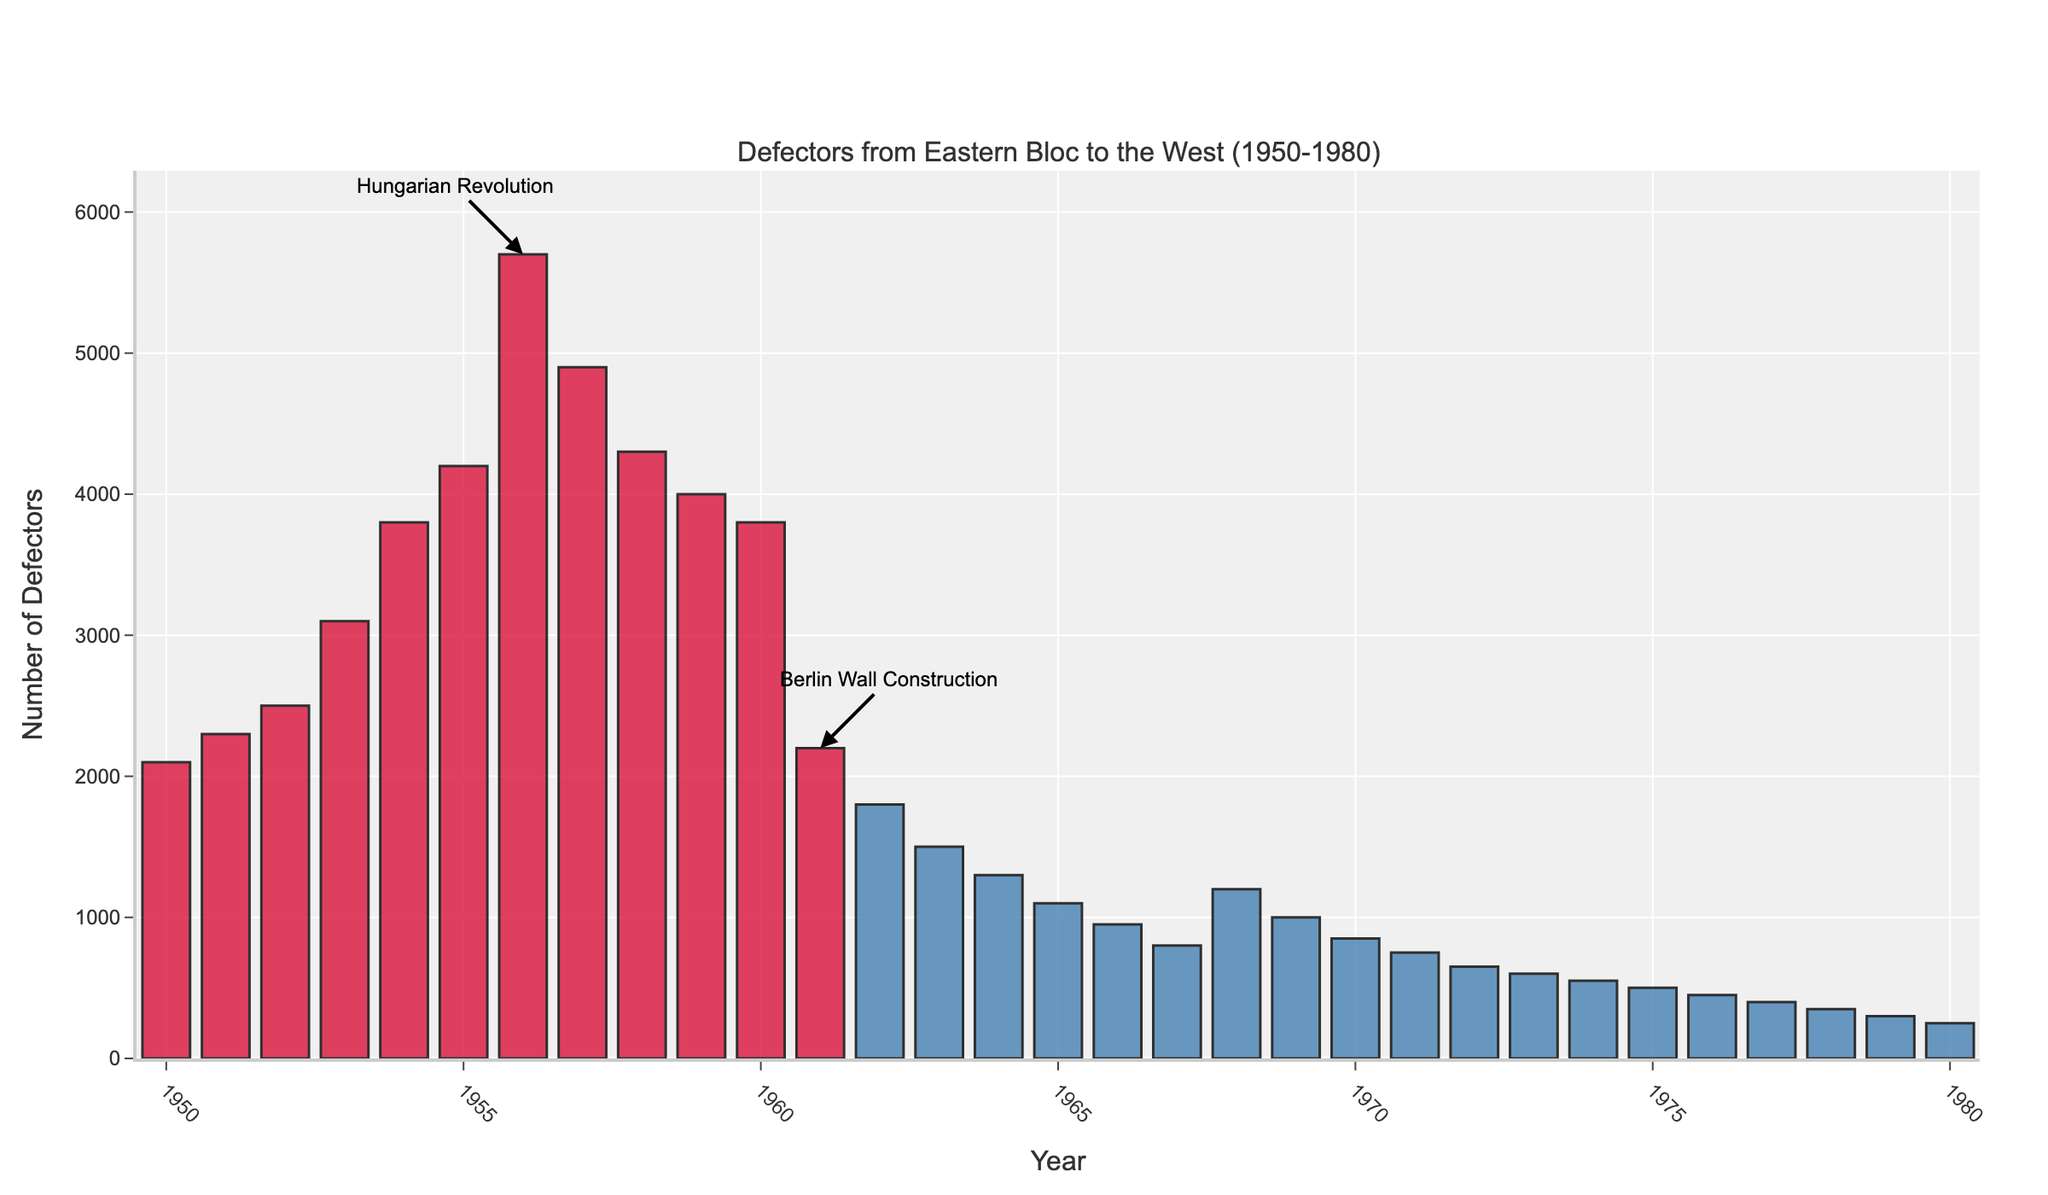Which year had the highest number of defectors? The year with the highest bar represents the highest number of defectors. In this case, the bar for 1956 is the tallest.
Answer: 1956 What is the overall trend in the number of defectors between 1950 and 1961? From the figure, the number of defectors generally increases from 1950 to 1956, then starts to decrease until 1961. This can be identified by the heights of the bars growing taller till 1956 and then shrinking.
Answer: Increasing until 1956, then decreasing until 1961 How many years had more than 4000 defectors? Identify bars that are taller than the 4000 mark on the y-axis. The years with bars above this mark are 1955, 1956, and 1957.
Answer: 3 What visual indication is given for the Hungarian Revolution? A textual annotation and an arrow pointing to the bar corresponding to the year 1956 indicate the Hungarian Revolution.
Answer: Annotation on 1956 How does the number of defectors in 1961 compare to 1962? Compare the heights of the bars for the two years. The bar for 1961 is taller than that of 1962.
Answer: 1961 is higher than 1962 What event is associated with the decrease in defectors starting from 1961? An annotation points to 1961 indicating the construction of the Berlin Wall as the associated event.
Answer: Construction of the Berlin Wall Calculate the average number of defectors from 1950 to 1955. Sum the defectors for the years 1950 to 1955 and then divide by the number of years. (2100 + 2300 + 2500 + 3100 + 3800 + 4200) / 6 = 3000
Answer: 3000 Compare the number of defectors between the first and last years shown. The bar for 1950 is significantly taller than the bar for 1980, indicating more defectors in 1950.
Answer: More in 1950 Did any year between 1961 and 1980 have defectors greater than 3000? Observe the height of bars between 1961 and 1980; none of these bars reach the 3000 mark.
Answer: No Which color indicates years with defectors higher than the average? The legend and the bar colors show that 'red' represents years with defectors higher than the average.
Answer: Red 